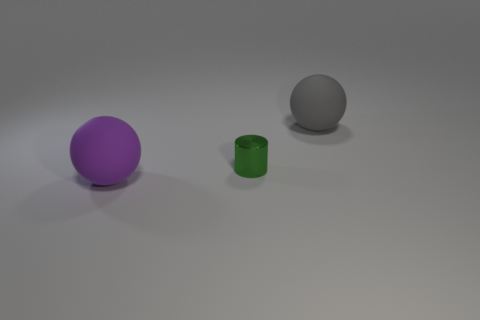Do the small object and the object on the left side of the green cylinder have the same shape?
Offer a very short reply. No. How many objects are either small green cylinders or green cylinders that are behind the purple ball?
Your response must be concise. 1. There is a gray thing that is the same shape as the purple thing; what is its material?
Give a very brief answer. Rubber. Is the shape of the big object in front of the big gray ball the same as  the green thing?
Provide a succinct answer. No. Is there anything else that is the same size as the purple rubber ball?
Make the answer very short. Yes. Are there fewer gray rubber spheres that are behind the tiny metal cylinder than gray rubber objects in front of the large gray object?
Ensure brevity in your answer.  No. What number of other objects are the same shape as the small shiny thing?
Ensure brevity in your answer.  0. How big is the matte thing behind the large sphere that is to the left of the large ball behind the large purple object?
Make the answer very short. Large. How many blue things are either large rubber objects or small things?
Your answer should be compact. 0. There is a small green thing in front of the large sphere on the right side of the small green cylinder; what is its shape?
Your answer should be very brief. Cylinder. 